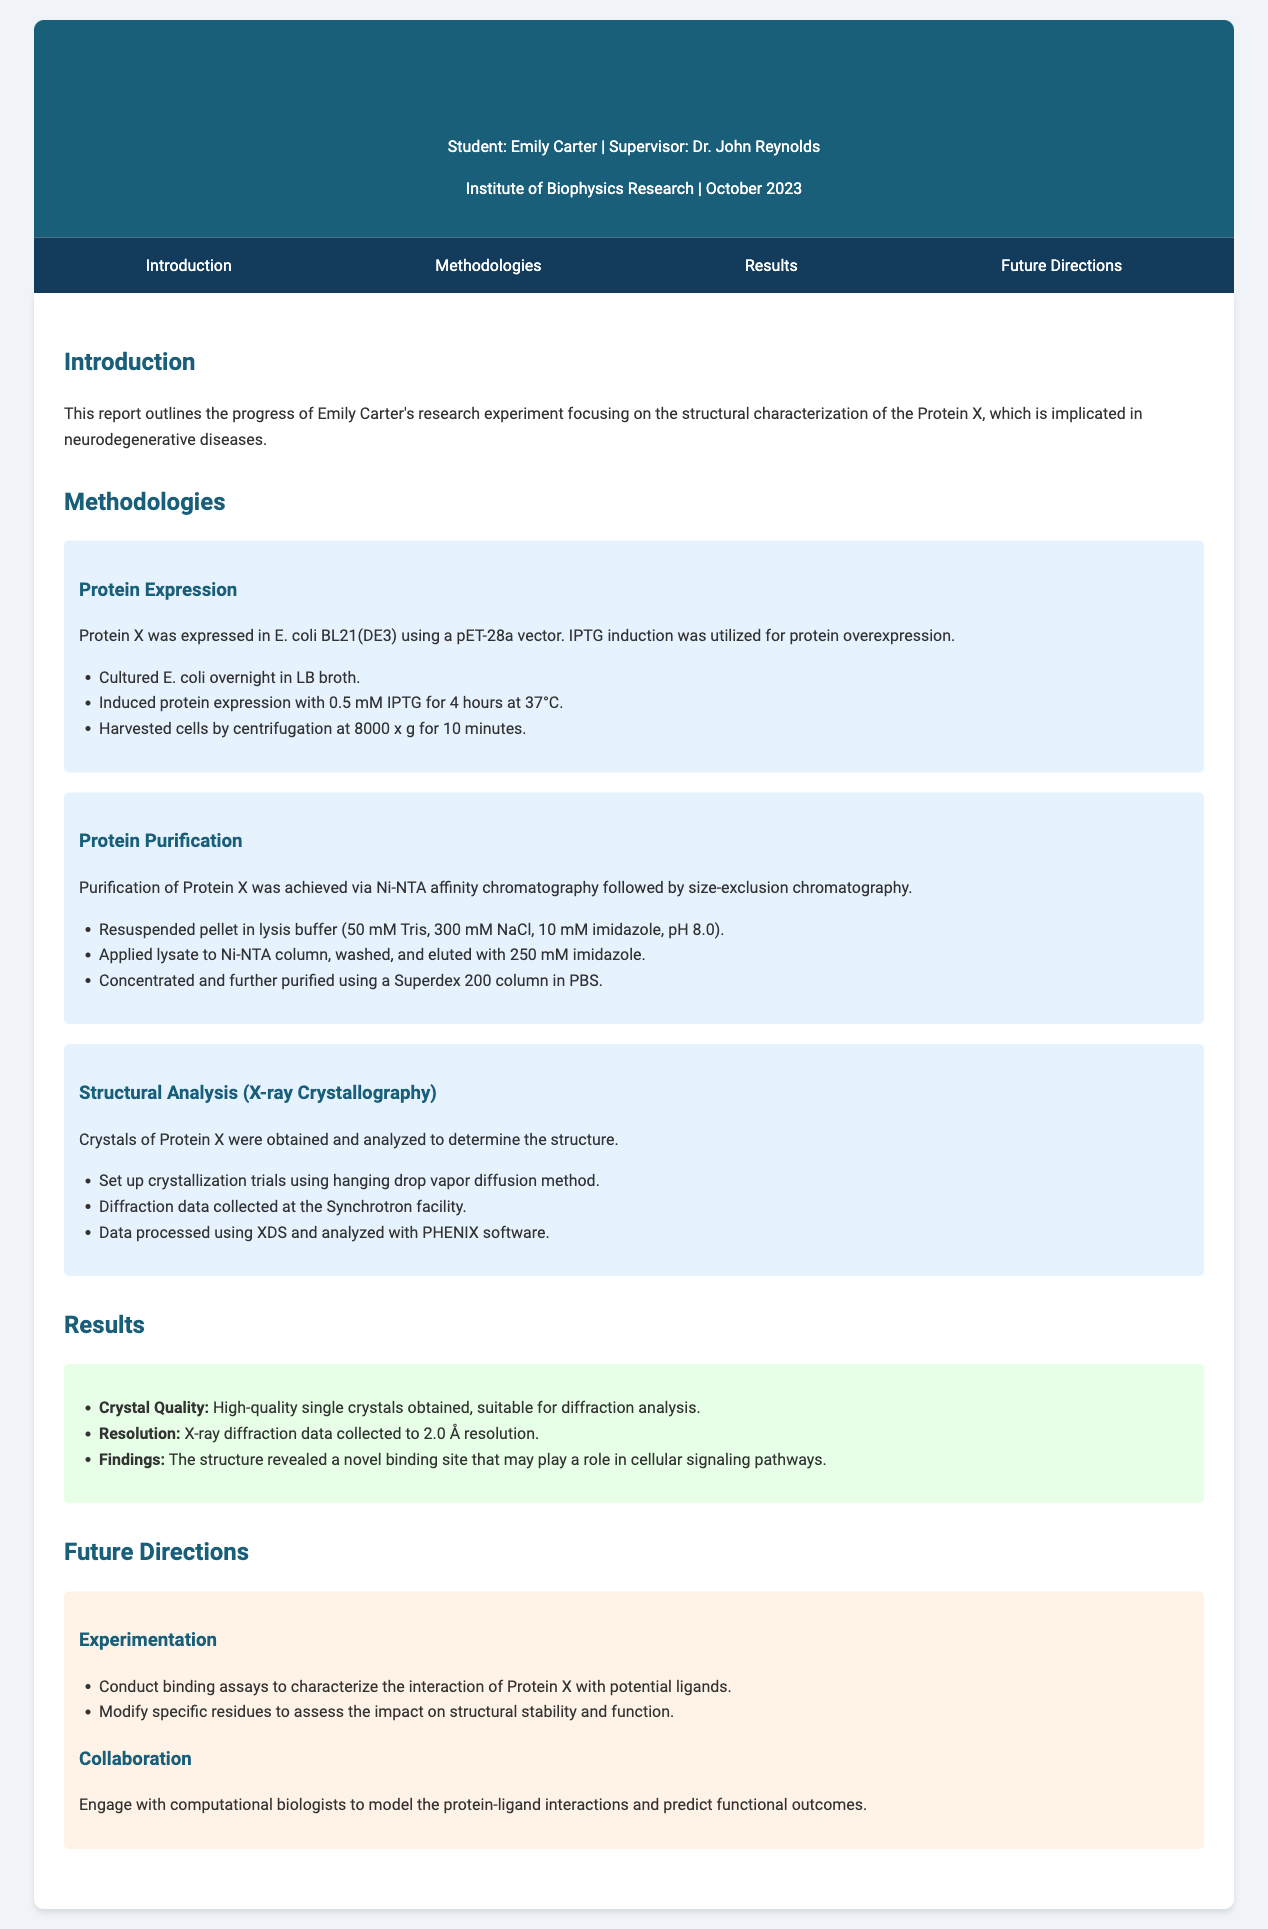what is the name of the student? The document explicitly states that the student is Emily Carter.
Answer: Emily Carter who is the supervisor of the student? The report mentions Dr. John Reynolds as the supervisor of Emily Carter.
Answer: Dr. John Reynolds what method was used for protein expression? The document indicates that the pET-28a vector was used for protein expression in E. coli.
Answer: pET-28a vector what was the resolution of the X-ray diffraction data? The report specifies that the X-ray diffraction data was collected to 2.0 Å resolution.
Answer: 2.0 Å what is one of the future directions mentioned in the report? The document lists conducting binding assays as a future research direction.
Answer: Conduct binding assays which chromatography method was used for protein purification? The report mentions Ni-NTA affinity chromatography as a part of the purification process.
Answer: Ni-NTA affinity chromatography how was protein X induced in E. coli? The document states that IPTG was used for inducing protein X in E. coli.
Answer: IPTG what structural analysis technique was employed in the research? The report indicates that X-ray crystallography was employed for structural analysis.
Answer: X-ray crystallography what kind of collaboration is suggested for future research? The report suggests engaging with computational biologists for future collaboration.
Answer: Engaging with computational biologists 